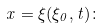Convert formula to latex. <formula><loc_0><loc_0><loc_500><loc_500>x = \xi ( \xi _ { 0 } , t ) \colon</formula> 